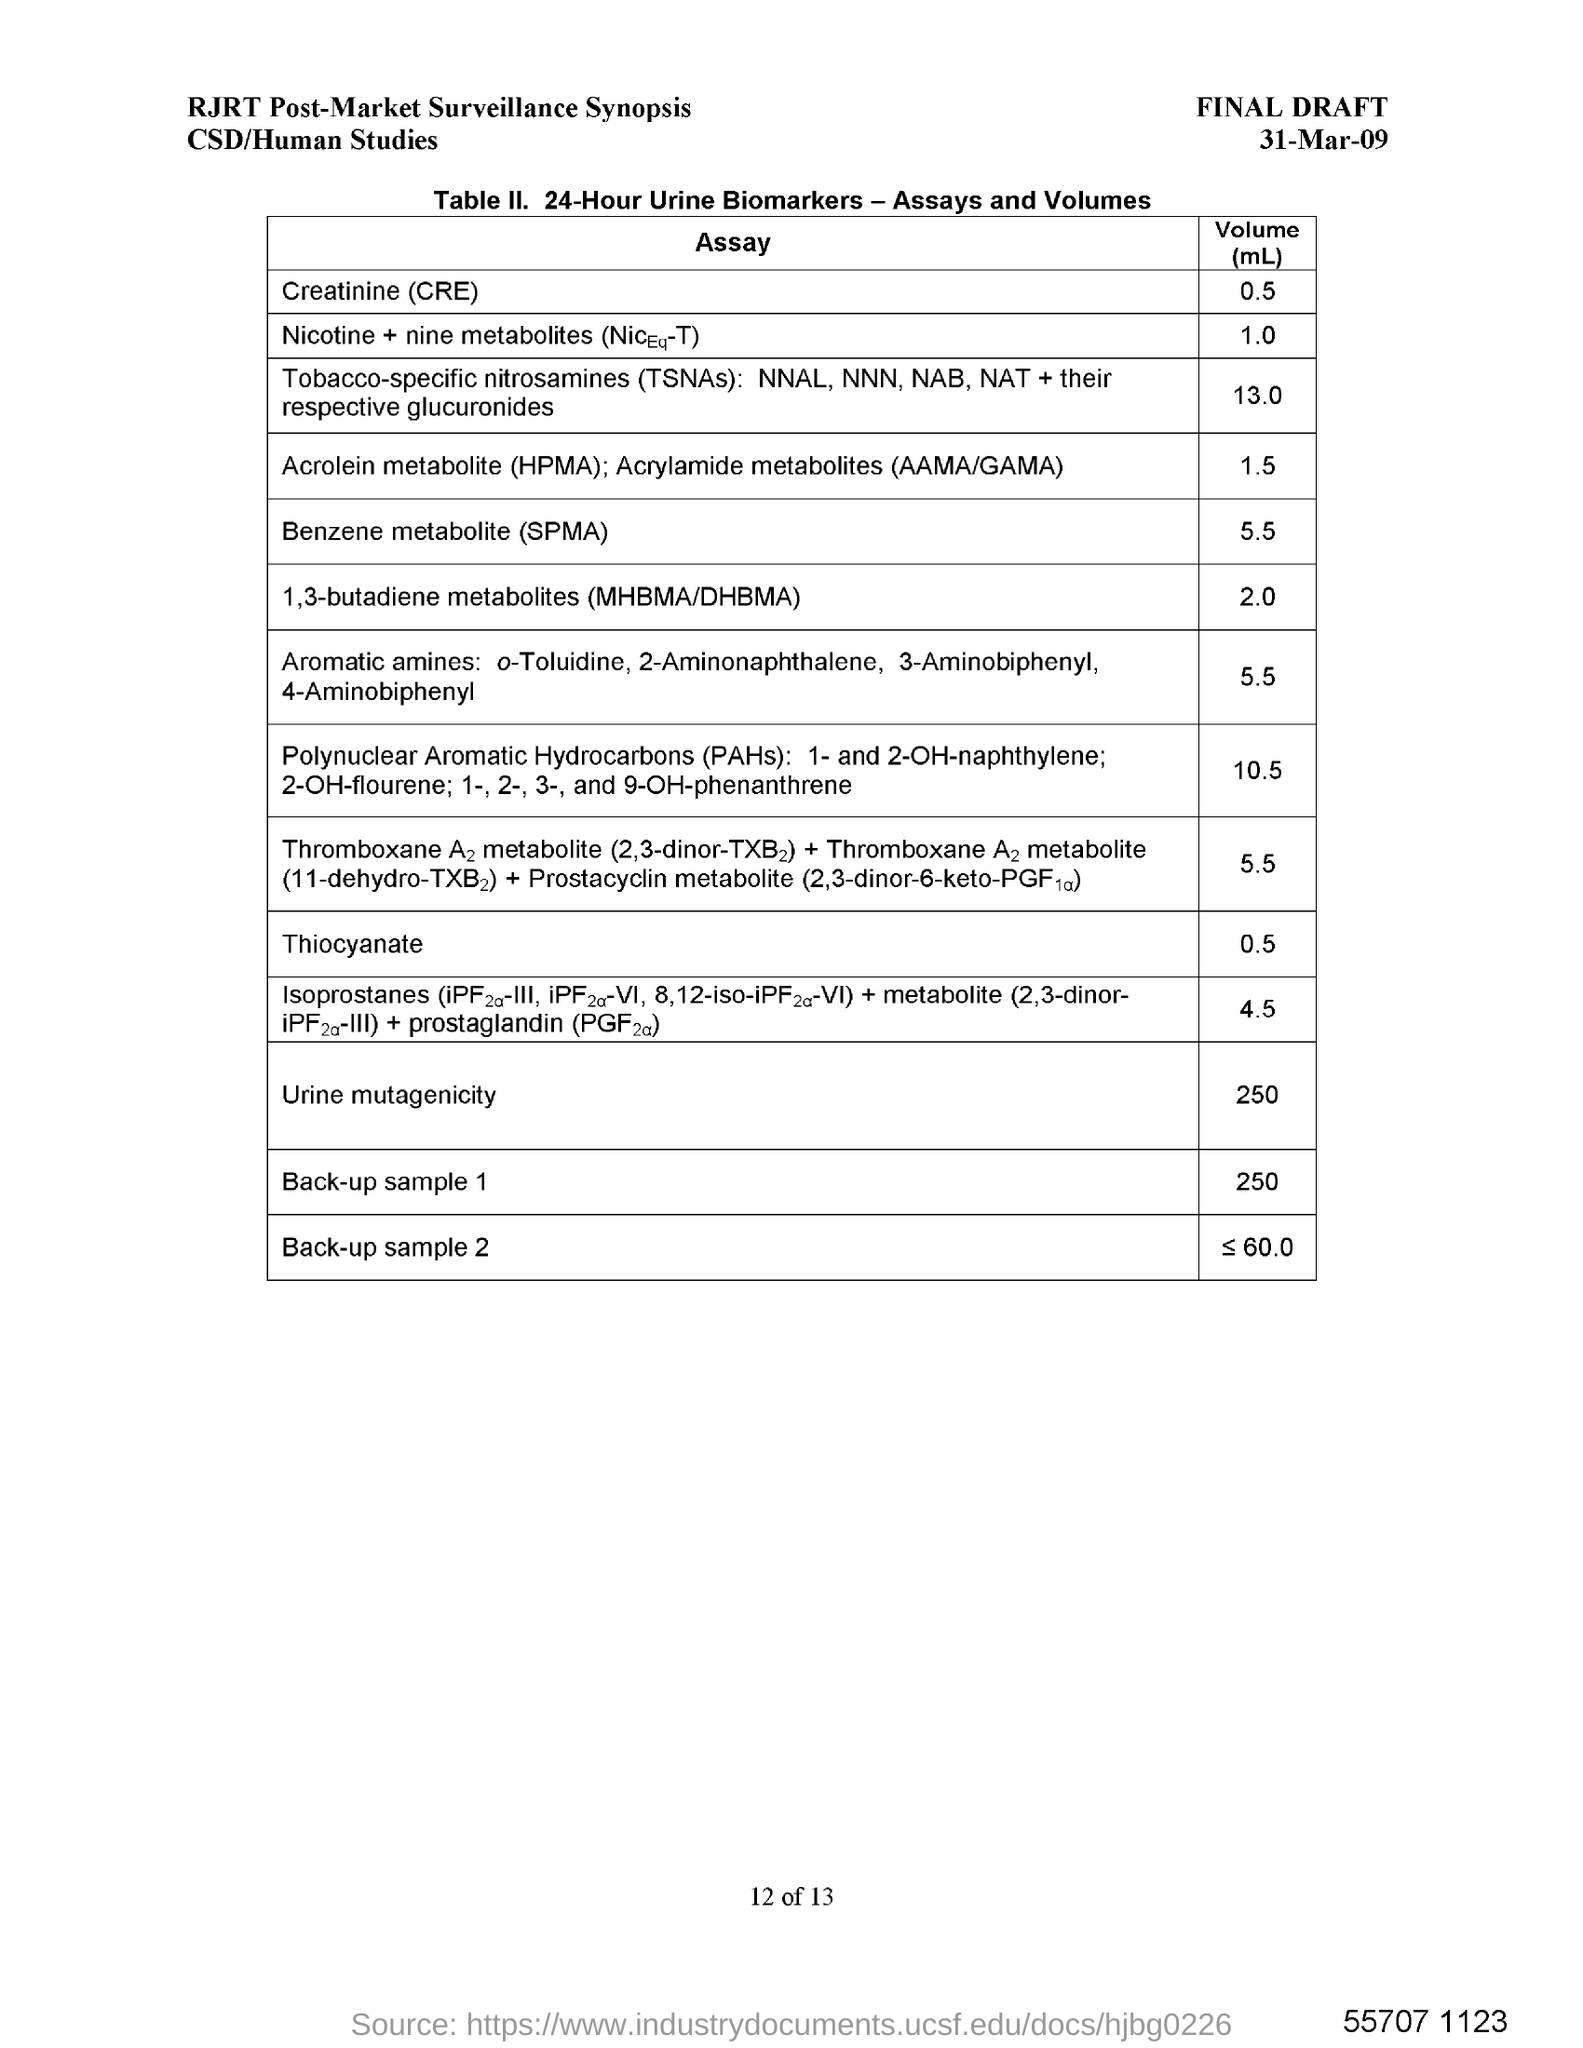What is the date in the draft?
Make the answer very short. 31-Mar-09. 